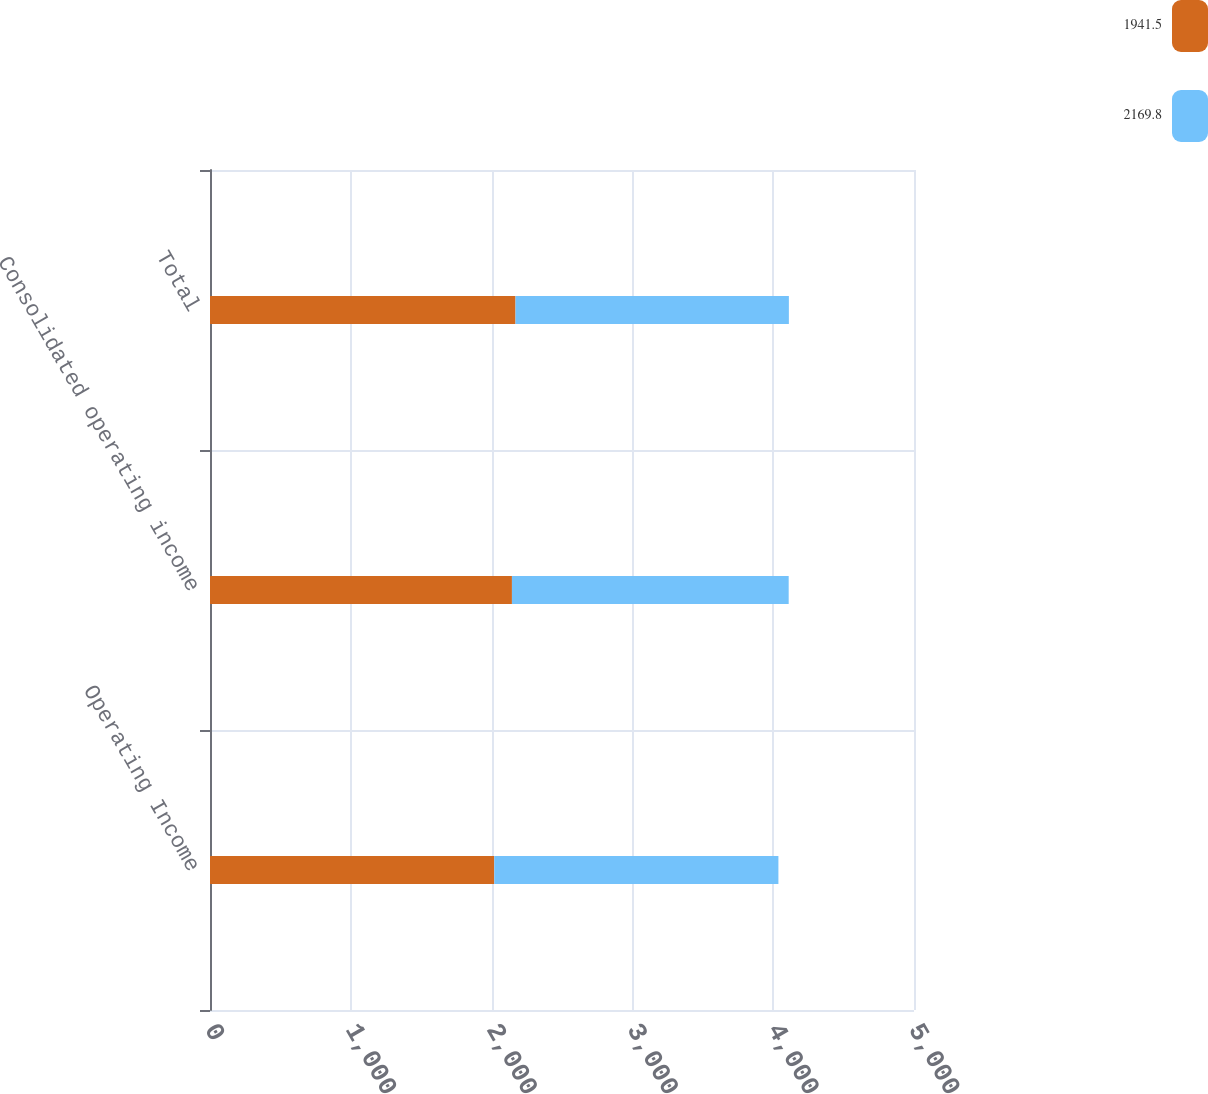Convert chart. <chart><loc_0><loc_0><loc_500><loc_500><stacked_bar_chart><ecel><fcel>Operating Income<fcel>Consolidated operating income<fcel>Total<nl><fcel>1941.5<fcel>2019<fcel>2144.4<fcel>2169.8<nl><fcel>2169.8<fcel>2018<fcel>1965.6<fcel>1941.5<nl></chart> 